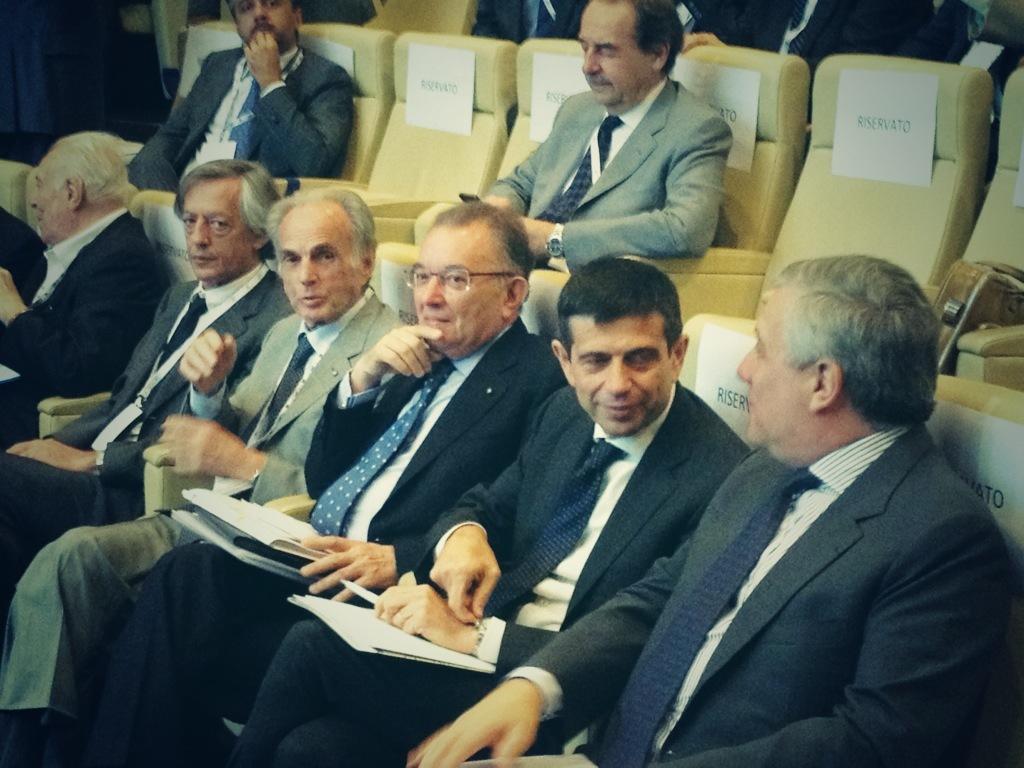How would you summarize this image in a sentence or two? In this image we can see few people sitting on chairs. On the chairs we can see papers with text. And there are few people holding something in the hand. 